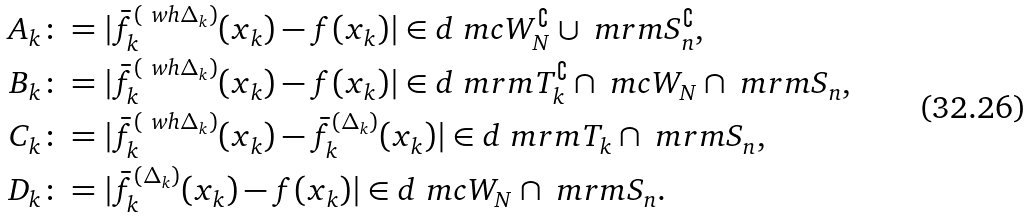<formula> <loc_0><loc_0><loc_500><loc_500>A _ { k } & \colon = | \bar { f } _ { k } ^ { ( \ w h \Delta _ { k } ) } ( x _ { k } ) - f ( x _ { k } ) | \in d { \ m c W _ { N } ^ { \complement } \cup \ m r m S _ { n } ^ { \complement } } , \\ B _ { k } & \colon = | \bar { f } _ { k } ^ { ( \ w h \Delta _ { k } ) } ( x _ { k } ) - f ( x _ { k } ) | \in d { \ m r m T _ { k } ^ { \complement } \cap \ m c W _ { N } \cap \ m r m S _ { n } } , \\ C _ { k } & \colon = | \bar { f } _ { k } ^ { ( \ w h \Delta _ { k } ) } ( x _ { k } ) - \bar { f } _ { k } ^ { ( \Delta _ { k } ) } ( x _ { k } ) | \in d { \ m r m T _ { k } \cap \ m r m S _ { n } } , \\ D _ { k } & \colon = | \bar { f } _ { k } ^ { ( \Delta _ { k } ) } ( x _ { k } ) - f ( x _ { k } ) | \in d { \ m c W _ { N } \cap \ m r m S _ { n } } .</formula> 